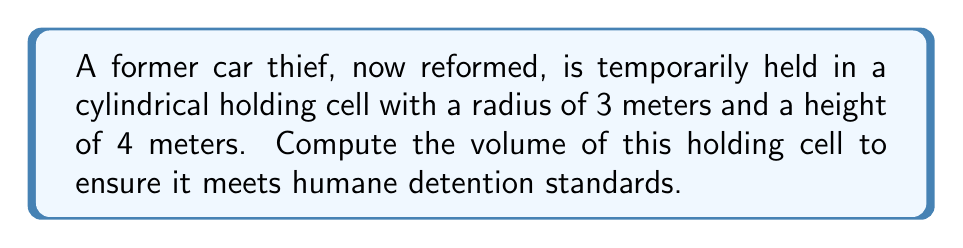Show me your answer to this math problem. To calculate the volume of a cylindrical holding cell, we use the formula for the volume of a cylinder:

$$V = \pi r^2 h$$

Where:
$V$ = volume
$r$ = radius of the base
$h$ = height of the cylinder

Given:
$r = 3$ meters
$h = 4$ meters

Step 1: Substitute the values into the formula
$$V = \pi (3\text{ m})^2 (4\text{ m})$$

Step 2: Simplify the expression inside the parentheses
$$V = \pi (9\text{ m}^2) (4\text{ m})$$

Step 3: Multiply the terms
$$V = 36\pi\text{ m}^3$$

Step 4: Calculate the final value (rounded to two decimal places)
$$V \approx 113.10\text{ m}^3$$

[asy]
import geometry;

real r = 3;
real h = 4;

draw(circle((0,0),r),blue);
draw((r,0)--(r,h),blue);
draw((0,h)--(r,h),blue);
draw((-r,0)--(-r,h),blue+dashed);
draw((0,0)--(0,h),blue+dashed);

label("r",(r/2,0),S);
label("h",(r,h/2),E);

[/asy]
Answer: $113.10\text{ m}^3$ 